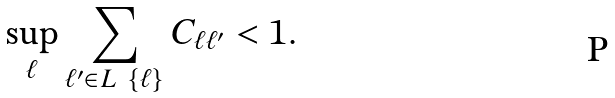Convert formula to latex. <formula><loc_0><loc_0><loc_500><loc_500>\sup _ { \ell } \sum _ { \ell ^ { \prime } \in L \ \{ \ell \} } C _ { \ell \ell ^ { \prime } } < 1 .</formula> 